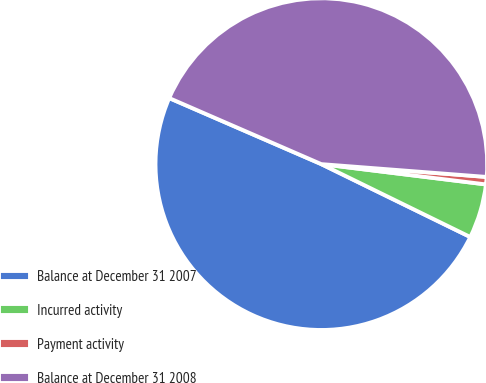<chart> <loc_0><loc_0><loc_500><loc_500><pie_chart><fcel>Balance at December 31 2007<fcel>Incurred activity<fcel>Payment activity<fcel>Balance at December 31 2008<nl><fcel>49.28%<fcel>5.29%<fcel>0.72%<fcel>44.71%<nl></chart> 